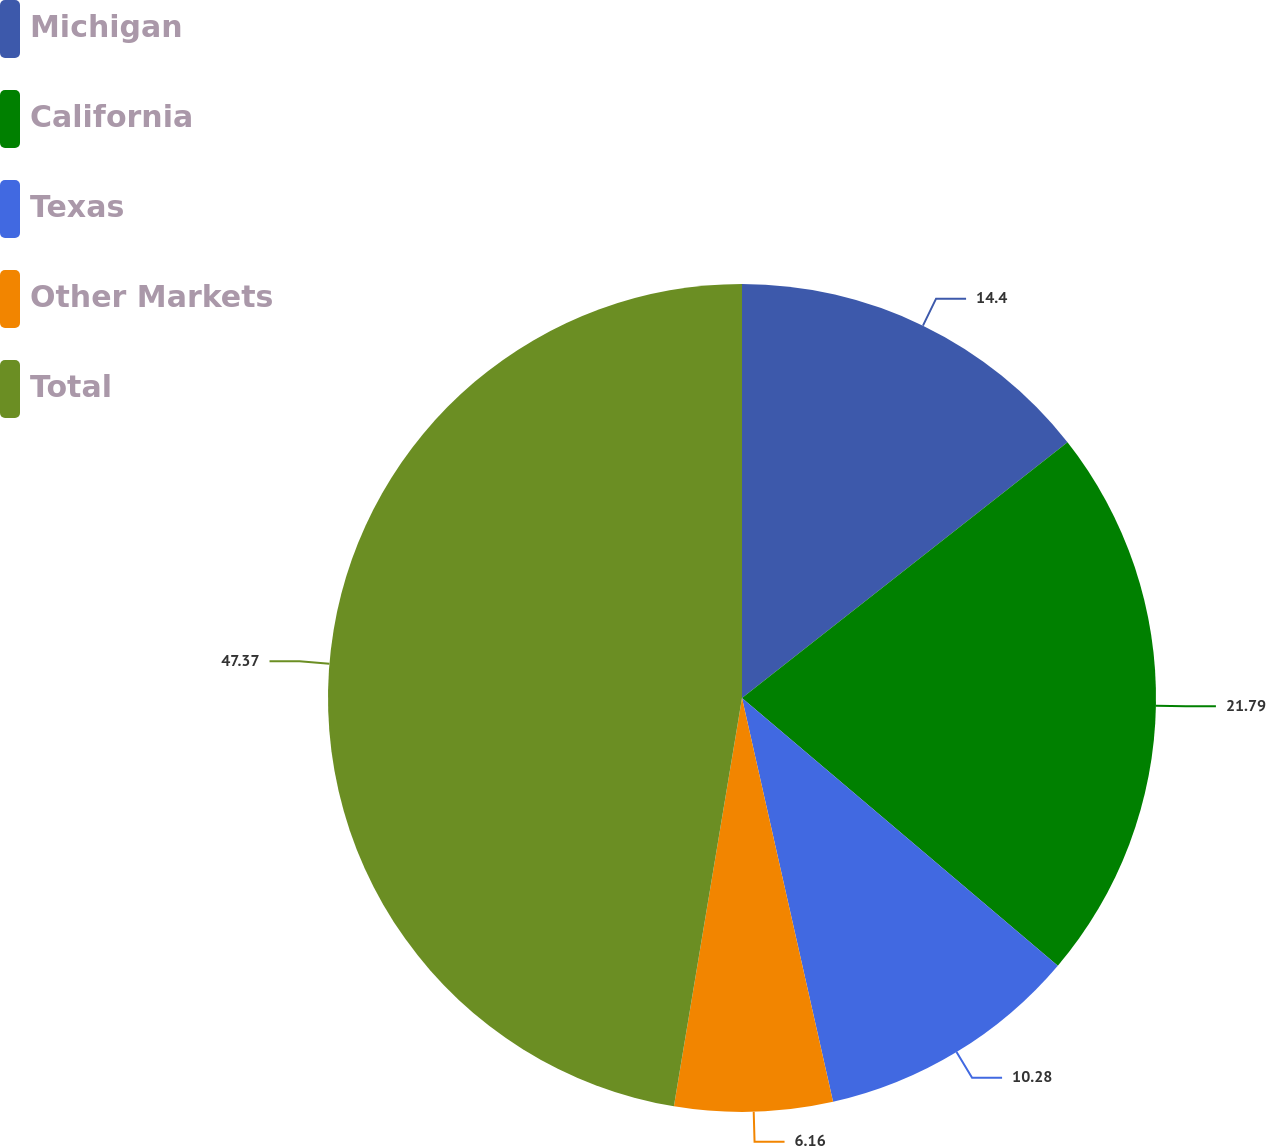<chart> <loc_0><loc_0><loc_500><loc_500><pie_chart><fcel>Michigan<fcel>California<fcel>Texas<fcel>Other Markets<fcel>Total<nl><fcel>14.4%<fcel>21.79%<fcel>10.28%<fcel>6.16%<fcel>47.37%<nl></chart> 